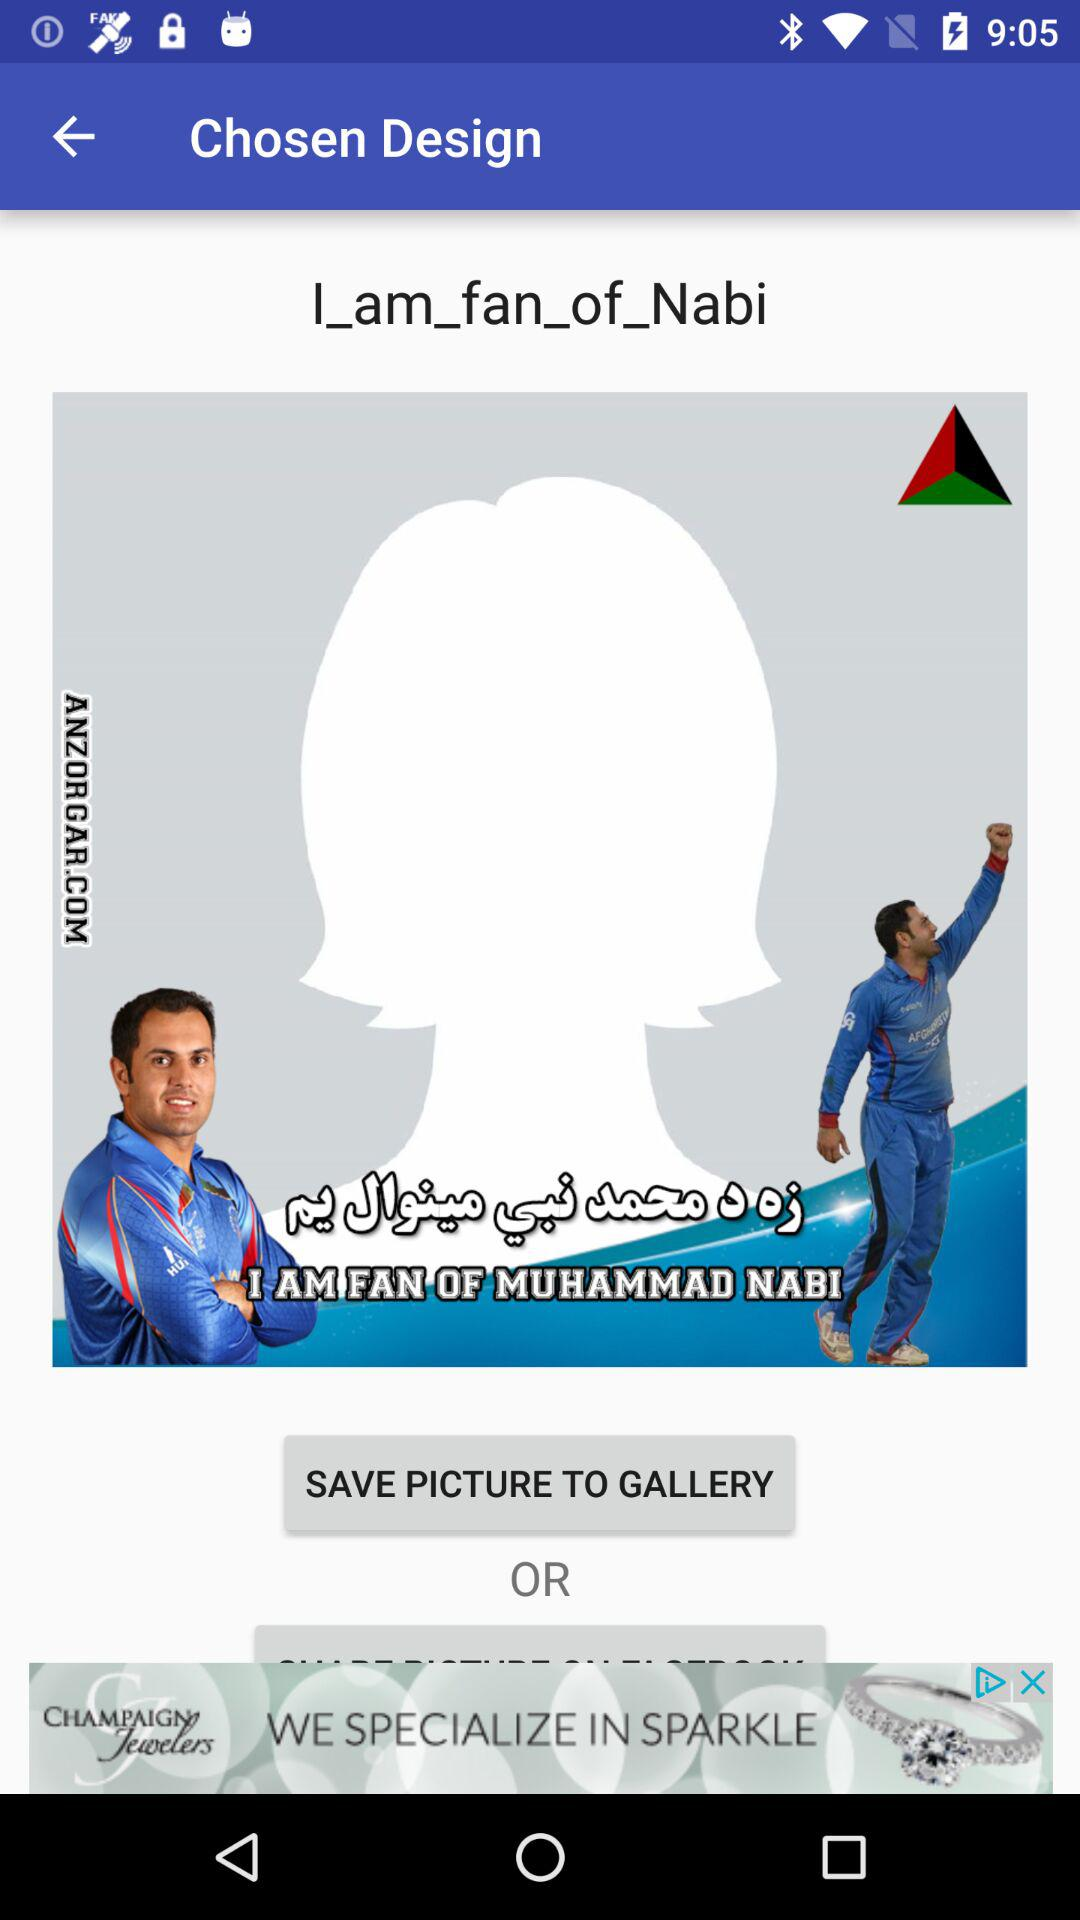What is the name of the sportsman? The name of the sportsman is Muhammad Nabi. 